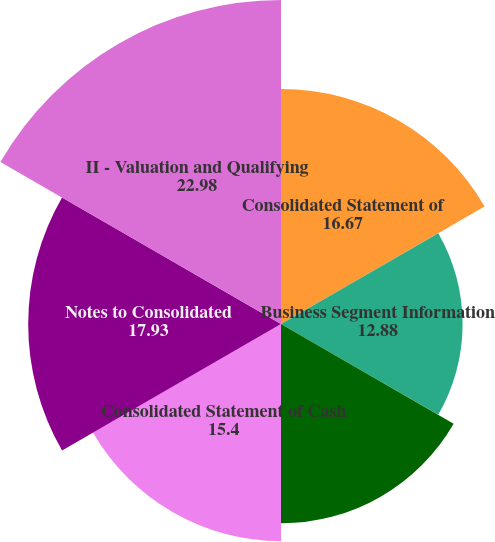Convert chart. <chart><loc_0><loc_0><loc_500><loc_500><pie_chart><fcel>Consolidated Statement of<fcel>Business Segment Information<fcel>Consolidated Balance Sheet<fcel>Consolidated Statement of Cash<fcel>Notes to Consolidated<fcel>II - Valuation and Qualifying<nl><fcel>16.67%<fcel>12.88%<fcel>14.14%<fcel>15.4%<fcel>17.93%<fcel>22.98%<nl></chart> 